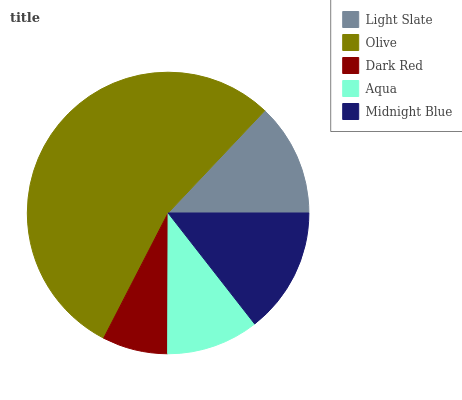Is Dark Red the minimum?
Answer yes or no. Yes. Is Olive the maximum?
Answer yes or no. Yes. Is Olive the minimum?
Answer yes or no. No. Is Dark Red the maximum?
Answer yes or no. No. Is Olive greater than Dark Red?
Answer yes or no. Yes. Is Dark Red less than Olive?
Answer yes or no. Yes. Is Dark Red greater than Olive?
Answer yes or no. No. Is Olive less than Dark Red?
Answer yes or no. No. Is Light Slate the high median?
Answer yes or no. Yes. Is Light Slate the low median?
Answer yes or no. Yes. Is Olive the high median?
Answer yes or no. No. Is Midnight Blue the low median?
Answer yes or no. No. 